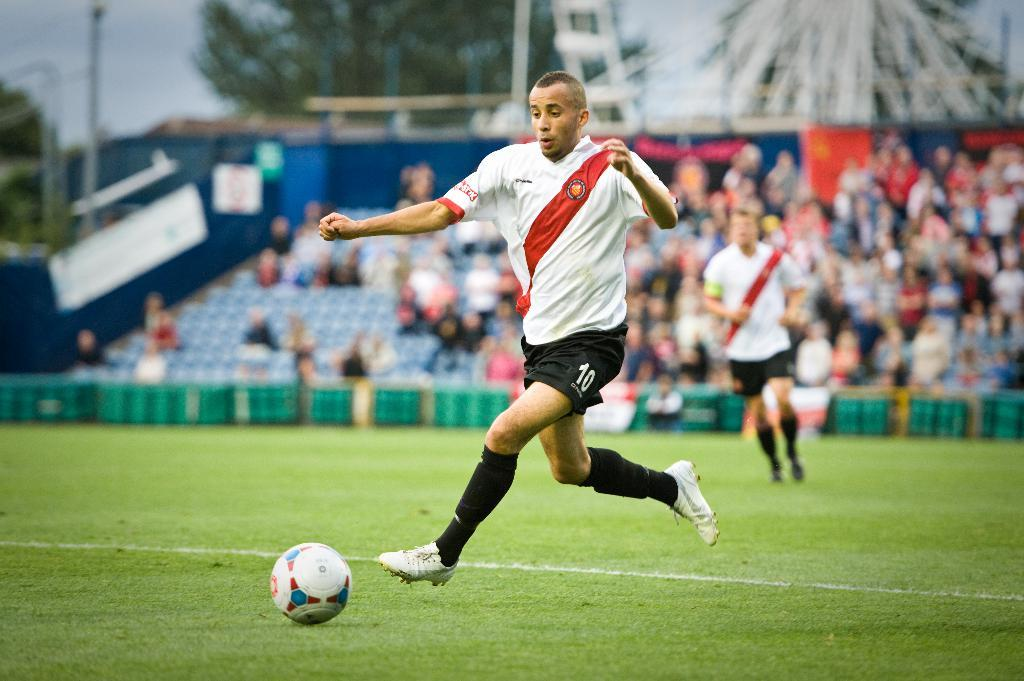<image>
Render a clear and concise summary of the photo. A soccer player no. 10 rushes in with the ball. 